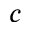<formula> <loc_0><loc_0><loc_500><loc_500>c</formula> 